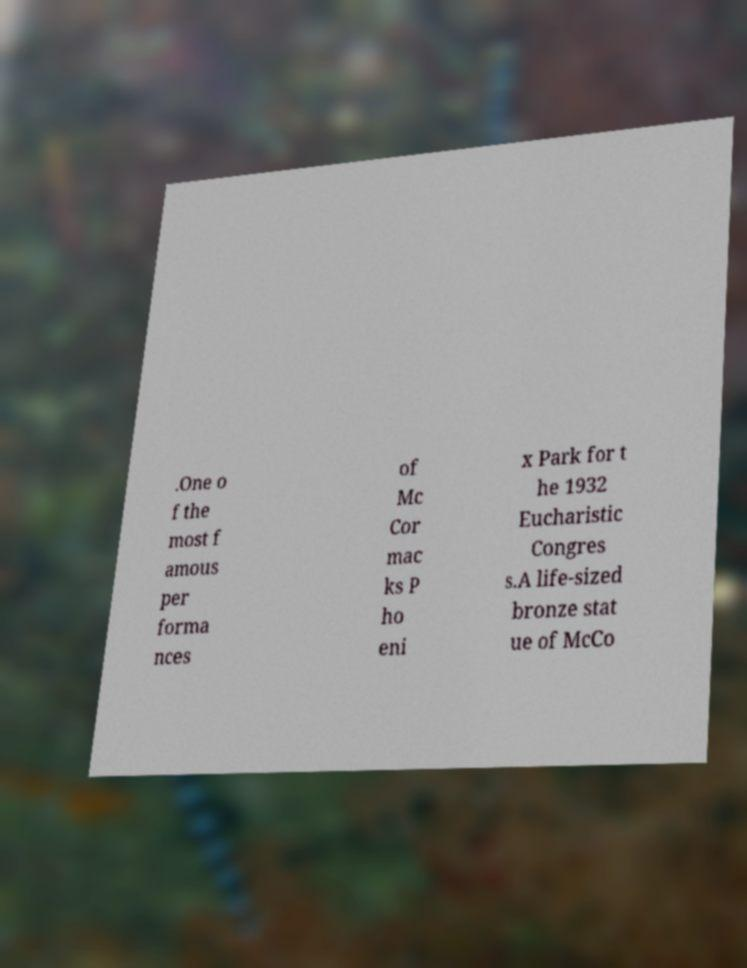For documentation purposes, I need the text within this image transcribed. Could you provide that? .One o f the most f amous per forma nces of Mc Cor mac ks P ho eni x Park for t he 1932 Eucharistic Congres s.A life-sized bronze stat ue of McCo 